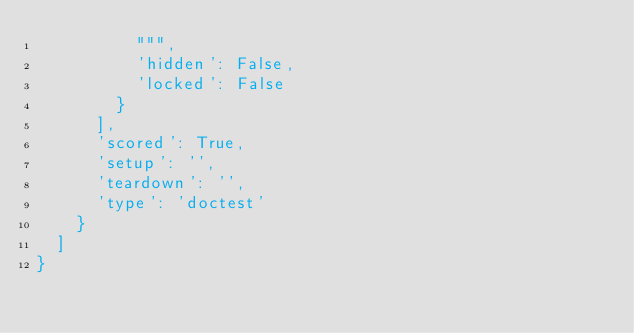Convert code to text. <code><loc_0><loc_0><loc_500><loc_500><_Python_>          """,
          'hidden': False,
          'locked': False
        }
      ],
      'scored': True,
      'setup': '',
      'teardown': '',
      'type': 'doctest'
    }
  ]
}
</code> 